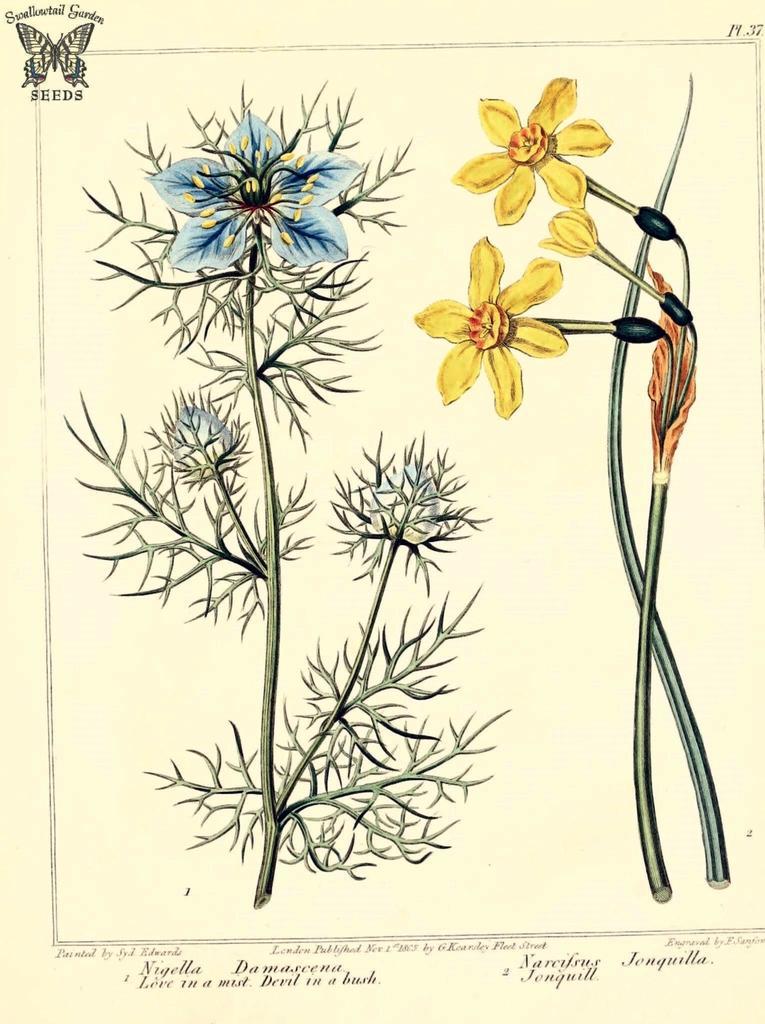Please provide a concise description of this image. In this picture there are two flowers which are blue and yellow in color and there is something written below it. 